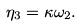Convert formula to latex. <formula><loc_0><loc_0><loc_500><loc_500>\eta _ { 3 } = \kappa \omega _ { 2 } .</formula> 